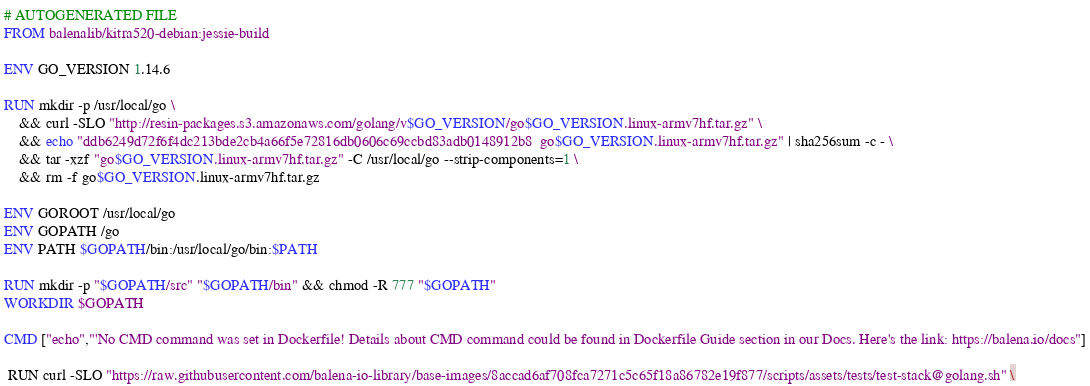Convert code to text. <code><loc_0><loc_0><loc_500><loc_500><_Dockerfile_># AUTOGENERATED FILE
FROM balenalib/kitra520-debian:jessie-build

ENV GO_VERSION 1.14.6

RUN mkdir -p /usr/local/go \
	&& curl -SLO "http://resin-packages.s3.amazonaws.com/golang/v$GO_VERSION/go$GO_VERSION.linux-armv7hf.tar.gz" \
	&& echo "ddb6249d72f6f4dc213bde2cb4a66f5e72816db0606c69ccbd83adb0148912b8  go$GO_VERSION.linux-armv7hf.tar.gz" | sha256sum -c - \
	&& tar -xzf "go$GO_VERSION.linux-armv7hf.tar.gz" -C /usr/local/go --strip-components=1 \
	&& rm -f go$GO_VERSION.linux-armv7hf.tar.gz

ENV GOROOT /usr/local/go
ENV GOPATH /go
ENV PATH $GOPATH/bin:/usr/local/go/bin:$PATH

RUN mkdir -p "$GOPATH/src" "$GOPATH/bin" && chmod -R 777 "$GOPATH"
WORKDIR $GOPATH

CMD ["echo","'No CMD command was set in Dockerfile! Details about CMD command could be found in Dockerfile Guide section in our Docs. Here's the link: https://balena.io/docs"]

 RUN curl -SLO "https://raw.githubusercontent.com/balena-io-library/base-images/8accad6af708fca7271c5c65f18a86782e19f877/scripts/assets/tests/test-stack@golang.sh" \</code> 